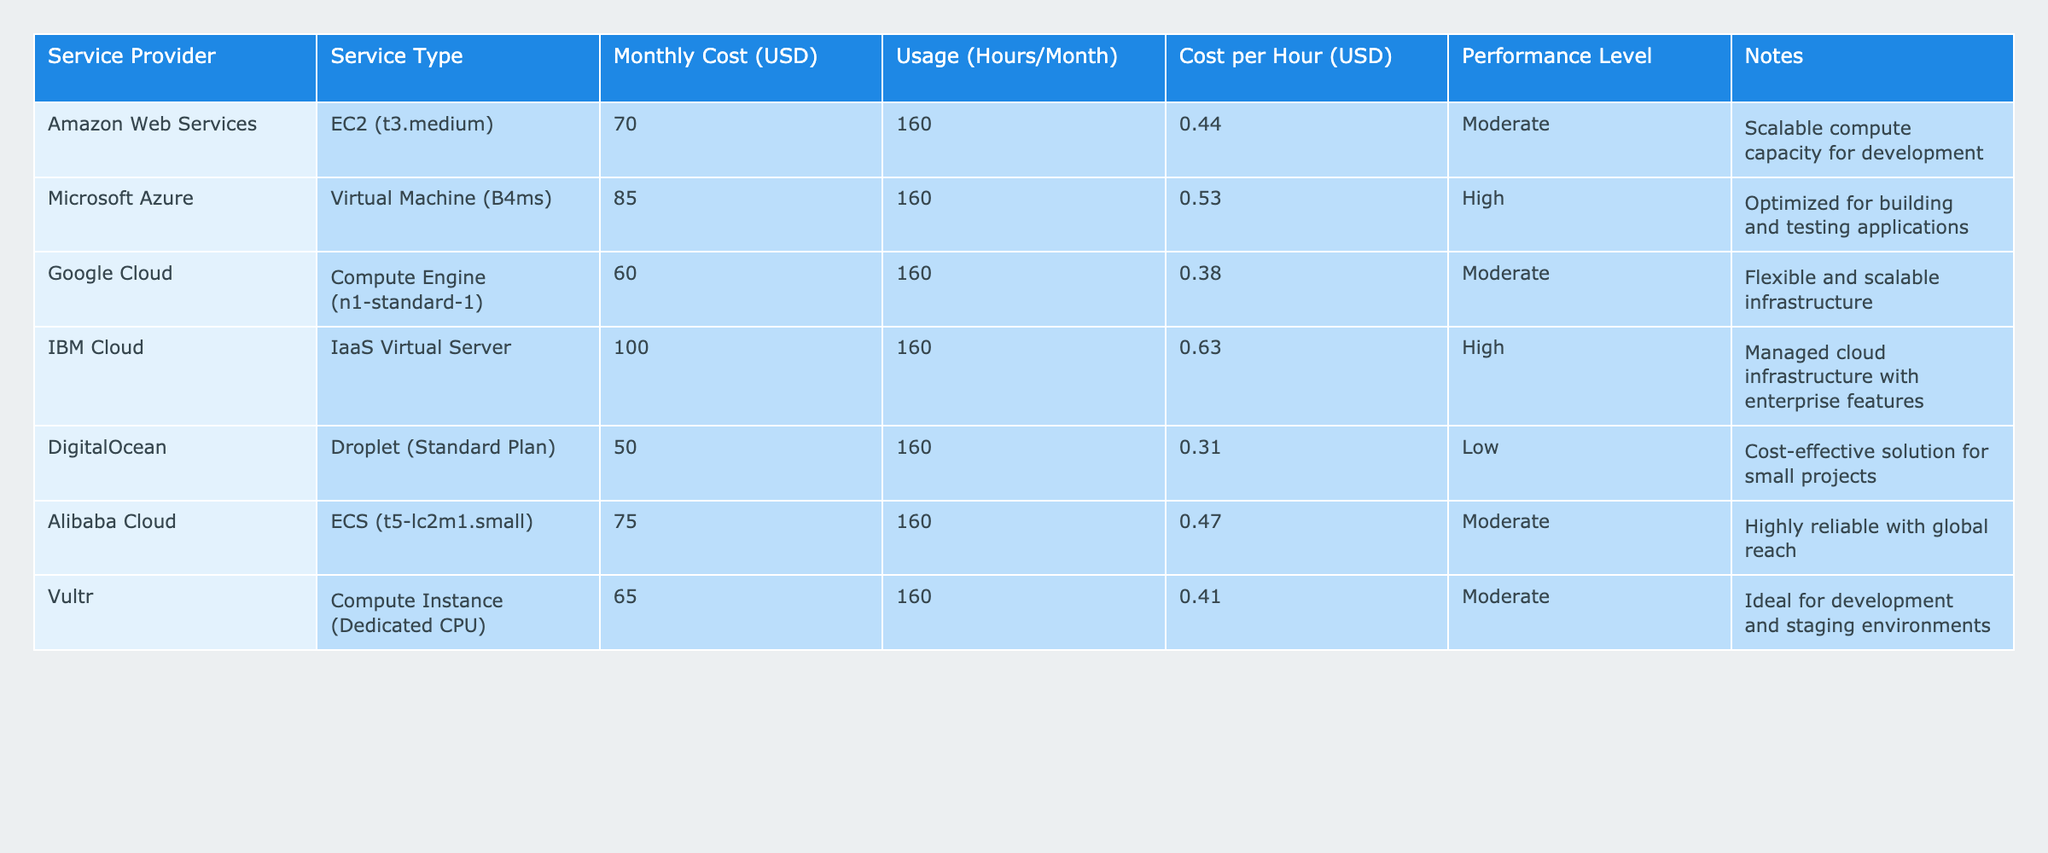What is the monthly cost of Microsoft Azure's Virtual Machine (B4ms)? The table shows that the Monthly Cost for Microsoft Azure's Virtual Machine (B4ms) is listed as 85 USD.
Answer: 85 USD What service provider offers the lowest cost per hour? By examining the Cost per Hour column, the lowest value is 0.31 USD which corresponds to DigitalOcean's Droplet (Standard Plan).
Answer: DigitalOcean What is the average monthly cost of the cloud services listed? To find the average, sum the monthly costs: 70 + 85 + 60 + 100 + 50 + 75 + 65 = 505. There are 7 services, so the average cost is 505 / 7 = 72.14 USD.
Answer: 72.14 USD Is IBM Cloud's IaaS Virtual Server the only high-performance option? The table shows that both Microsoft Azure's Virtual Machine (B4ms) and IBM Cloud's IaaS Virtual Server are high-performance options, thus the statement is false.
Answer: No Which service provider has the highest monthly cost? By looking through the Monthly Cost column, IBM Cloud's IaaS Virtual Server has the highest cost at 100 USD.
Answer: IBM Cloud What is the difference in cost per hour between Amazon Web Services and Google Cloud? Amazon Web Services has a cost per hour of 0.44 USD, and Google Cloud has 0.38 USD. The difference is 0.44 - 0.38 = 0.06 USD.
Answer: 0.06 USD Which service provides a more cost-efficient solution for small projects, DigitalOcean or Alibaba Cloud? DigitalOcean's cost per hour is 0.31 USD while Alibaba Cloud's is 0.47 USD. Since DigitalOcean is lower, it is the more cost-efficient solution.
Answer: DigitalOcean If we combine the costs of all services from Amazon Web Services, Google Cloud, and DigitalOcean, what is the total? The monthly costs for these services are 70 USD (AWS) + 60 USD (Google Cloud) + 50 USD (DigitalOcean), which sums up to 180 USD.
Answer: 180 USD Are there any services listed with a performance level categorized as low? The table indicates that DigitalOcean's service has a performance level categorized as low, so yes, there is a service with that classification.
Answer: Yes 